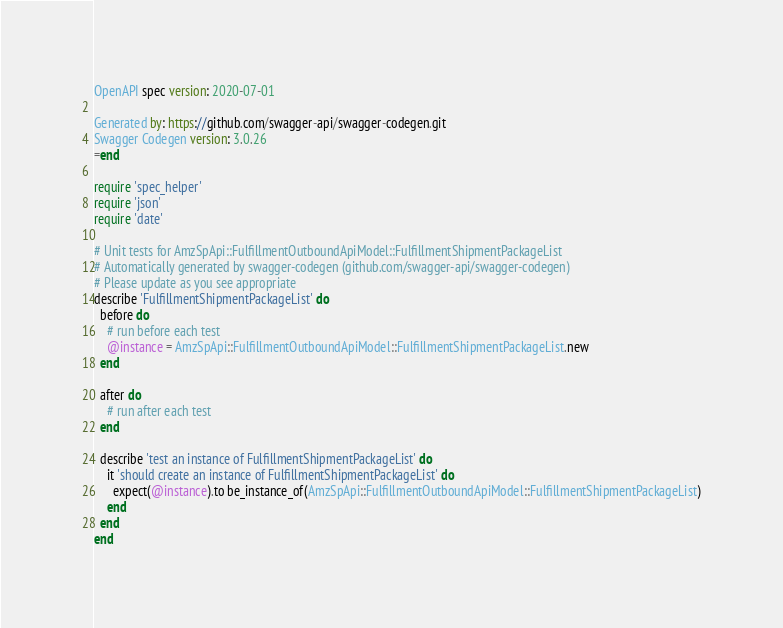<code> <loc_0><loc_0><loc_500><loc_500><_Ruby_>OpenAPI spec version: 2020-07-01

Generated by: https://github.com/swagger-api/swagger-codegen.git
Swagger Codegen version: 3.0.26
=end

require 'spec_helper'
require 'json'
require 'date'

# Unit tests for AmzSpApi::FulfillmentOutboundApiModel::FulfillmentShipmentPackageList
# Automatically generated by swagger-codegen (github.com/swagger-api/swagger-codegen)
# Please update as you see appropriate
describe 'FulfillmentShipmentPackageList' do
  before do
    # run before each test
    @instance = AmzSpApi::FulfillmentOutboundApiModel::FulfillmentShipmentPackageList.new
  end

  after do
    # run after each test
  end

  describe 'test an instance of FulfillmentShipmentPackageList' do
    it 'should create an instance of FulfillmentShipmentPackageList' do
      expect(@instance).to be_instance_of(AmzSpApi::FulfillmentOutboundApiModel::FulfillmentShipmentPackageList)
    end
  end
end
</code> 